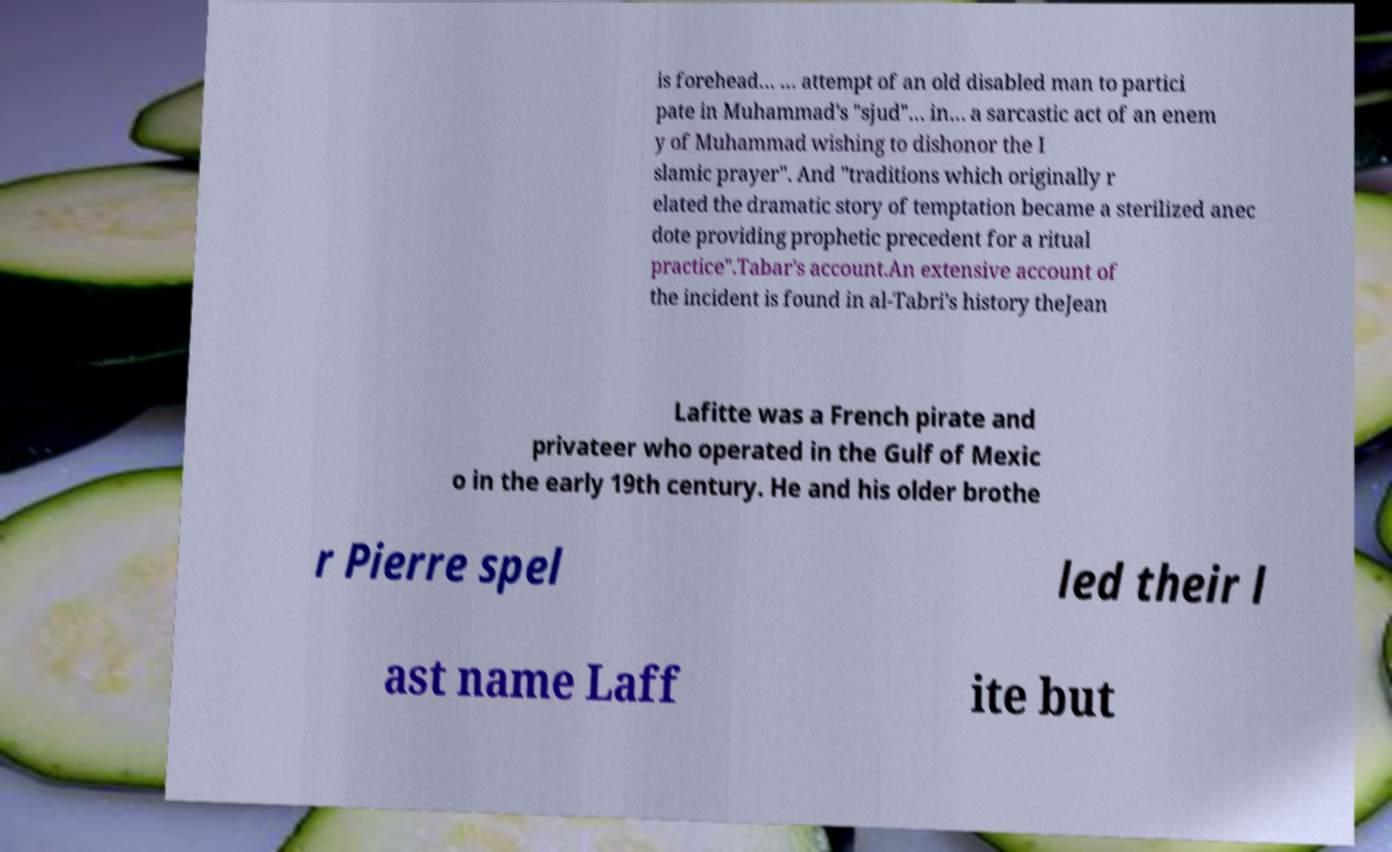Could you extract and type out the text from this image? is forehead… … attempt of an old disabled man to partici pate in Muhammad's "sjud"… in… a sarcastic act of an enem y of Muhammad wishing to dishonor the I slamic prayer". And "traditions which originally r elated the dramatic story of temptation became a sterilized anec dote providing prophetic precedent for a ritual practice".Tabar's account.An extensive account of the incident is found in al-Tabri's history theJean Lafitte was a French pirate and privateer who operated in the Gulf of Mexic o in the early 19th century. He and his older brothe r Pierre spel led their l ast name Laff ite but 